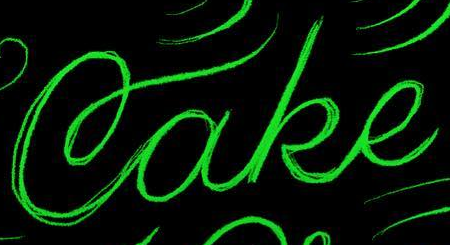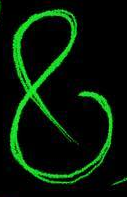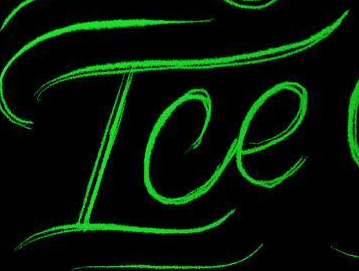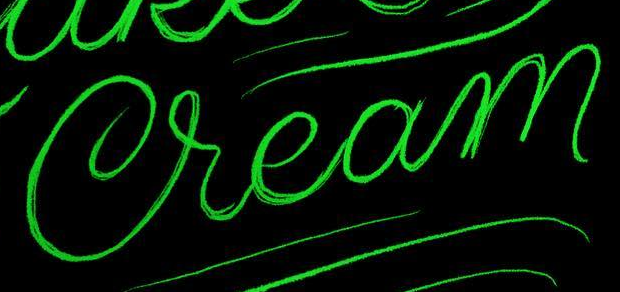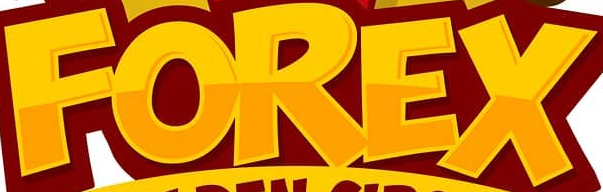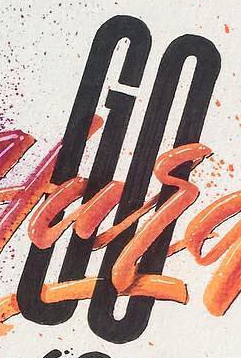What words can you see in these images in sequence, separated by a semicolon? Cake; &; Ice; Cream; FOREX; GO 